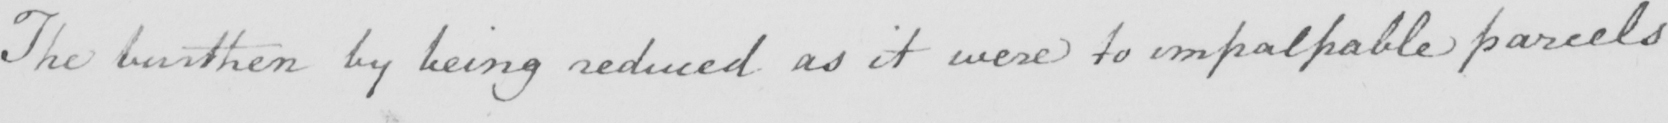Can you tell me what this handwritten text says? The burthen by being reduced as it were to impalpable parcels 